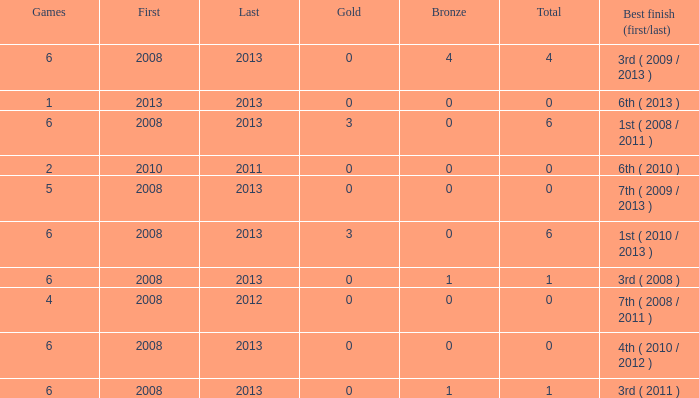What is the fewest number of medals associated with under 6 games and over 0 golds? None. 